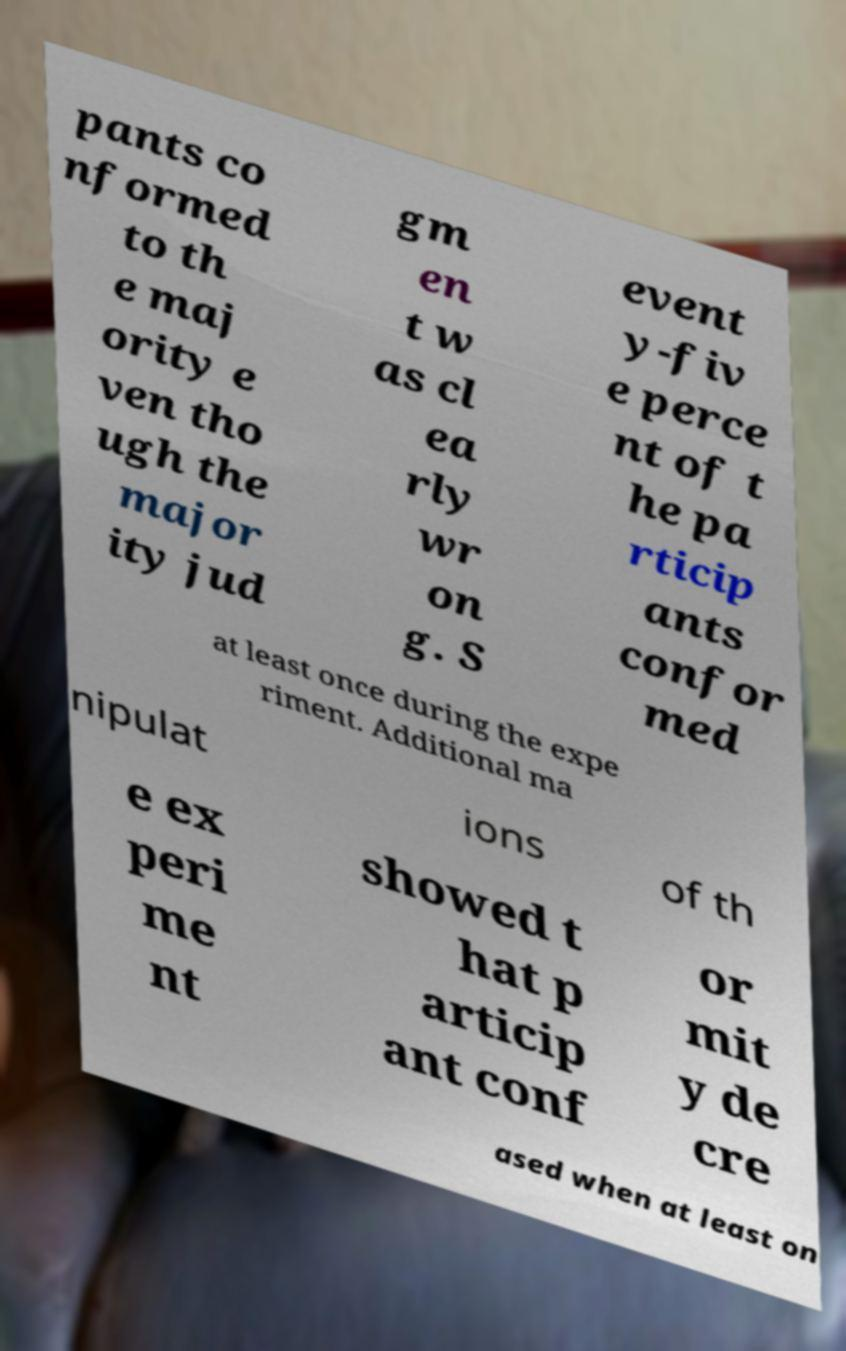Can you accurately transcribe the text from the provided image for me? pants co nformed to th e maj ority e ven tho ugh the major ity jud gm en t w as cl ea rly wr on g. S event y-fiv e perce nt of t he pa rticip ants confor med at least once during the expe riment. Additional ma nipulat ions of th e ex peri me nt showed t hat p articip ant conf or mit y de cre ased when at least on 